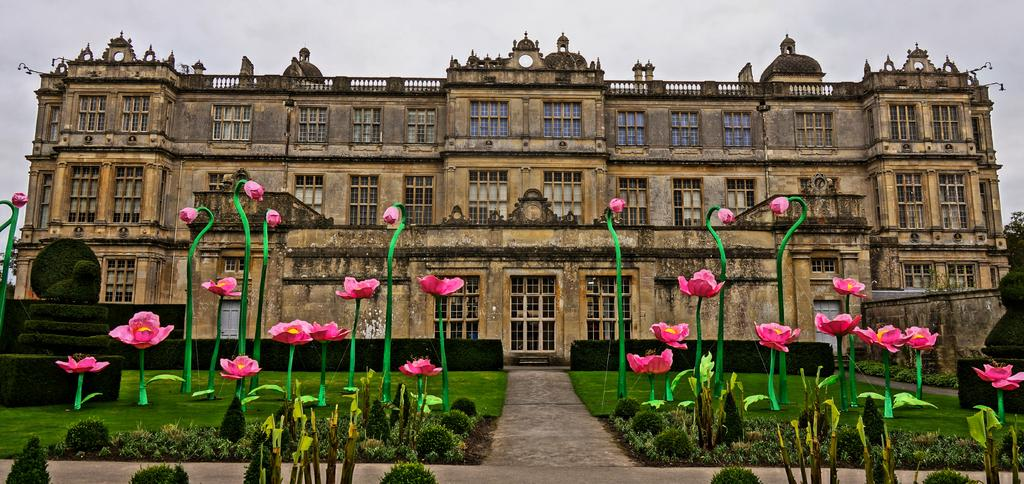What type of structure is present in the image? There is a building in the image. What type of vegetation can be seen in the image? There is grass, plants, flowers, and trees in the image. What is visible in the background of the image? The sky is visible in the background of the image. What verse can be heard recited by the flowers in the image? There are no verses or sounds associated with the flowers in the image; they are simply depicted as plants. 